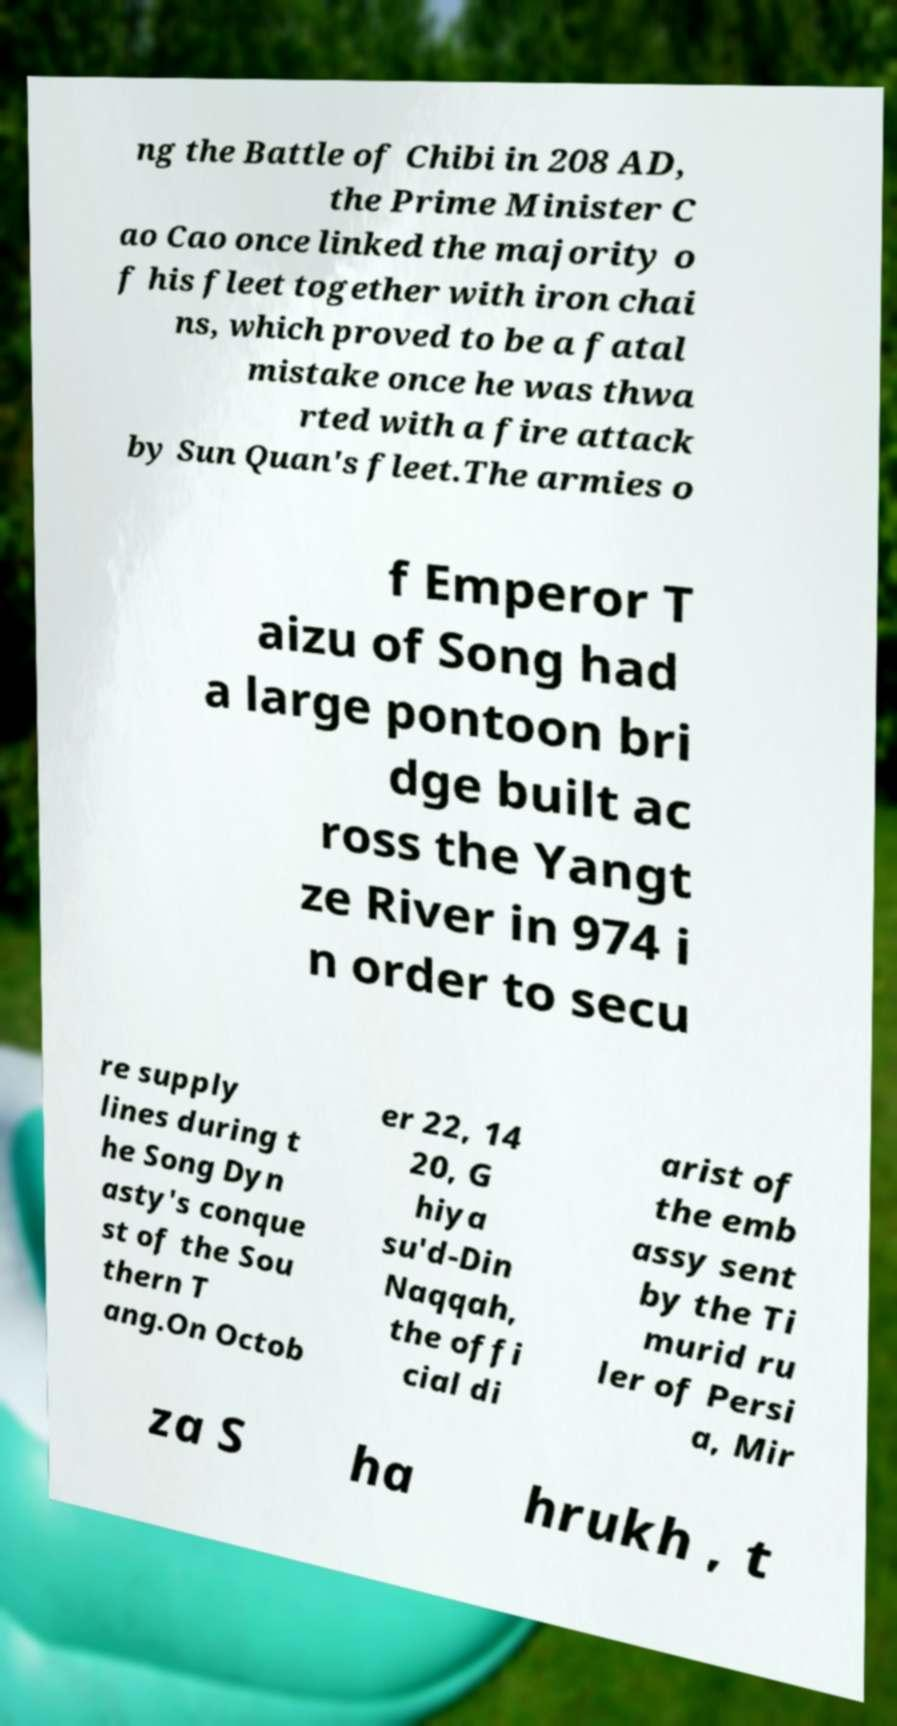What messages or text are displayed in this image? I need them in a readable, typed format. ng the Battle of Chibi in 208 AD, the Prime Minister C ao Cao once linked the majority o f his fleet together with iron chai ns, which proved to be a fatal mistake once he was thwa rted with a fire attack by Sun Quan's fleet.The armies o f Emperor T aizu of Song had a large pontoon bri dge built ac ross the Yangt ze River in 974 i n order to secu re supply lines during t he Song Dyn asty's conque st of the Sou thern T ang.On Octob er 22, 14 20, G hiya su'd-Din Naqqah, the offi cial di arist of the emb assy sent by the Ti murid ru ler of Persi a, Mir za S ha hrukh , t 